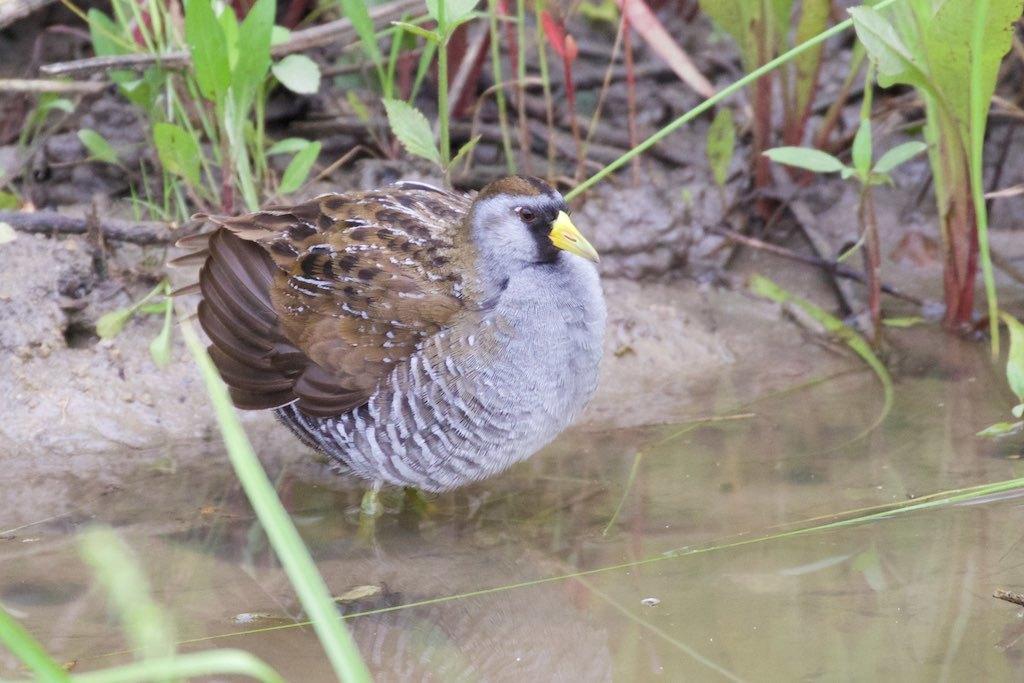How would you summarize this image in a sentence or two? In this picture we can see a bird, water and in the background we can see plants and sticks. 